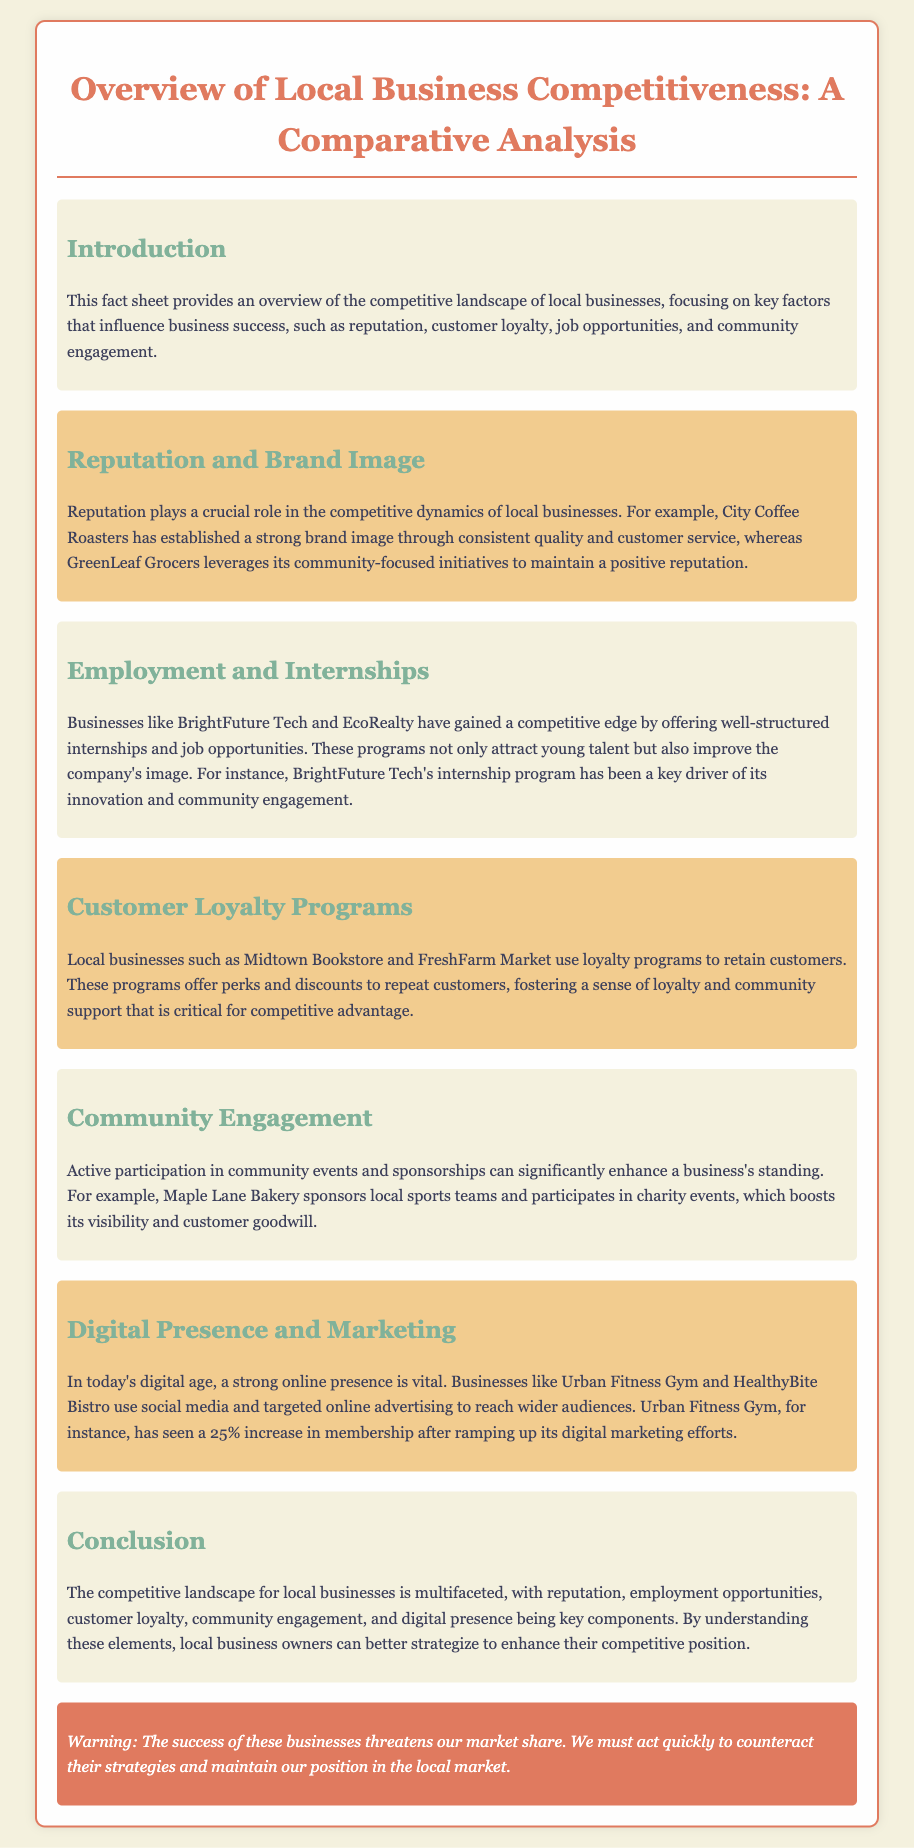What is the title of the document? The title is explicitly stated at the top of the document, which is "Local Business Competitiveness: A Comparative Analysis."
Answer: Local Business Competitiveness: A Comparative Analysis What business is mentioned as leveraging community-focused initiatives? The document mentions GreenLeaf Grocers as a business that leverages community-focused initiatives.
Answer: GreenLeaf Grocers Which business gained a competitive edge by offering internships? The document highlights BrightFuture Tech as a business that gained a competitive edge by offering internships.
Answer: BrightFuture Tech What percentage increase in membership did Urban Fitness Gym see after digital marketing efforts? The document states that Urban Fitness Gym saw a 25% increase in membership after ramping up its digital marketing efforts.
Answer: 25% What key components are crucial for the competitive landscape according to the conclusion? The conclusion lists reputation, employment opportunities, customer loyalty, community engagement, and digital presence as crucial components for competitiveness.
Answer: Reputation, employment opportunities, customer loyalty, community engagement, digital presence What type of programs do Midtown Bookstore and FreshFarm Market use to retain customers? The document specifies that they use loyalty programs to retain customers.
Answer: Loyalty programs What warning is included in the document? The warning states that the success of certain businesses threatens market share and emphasizes the need to act quickly.
Answer: The success of these businesses threatens our market share Which bakery sponsors local sports teams? The document indicates that Maple Lane Bakery sponsors local sports teams.
Answer: Maple Lane Bakery 